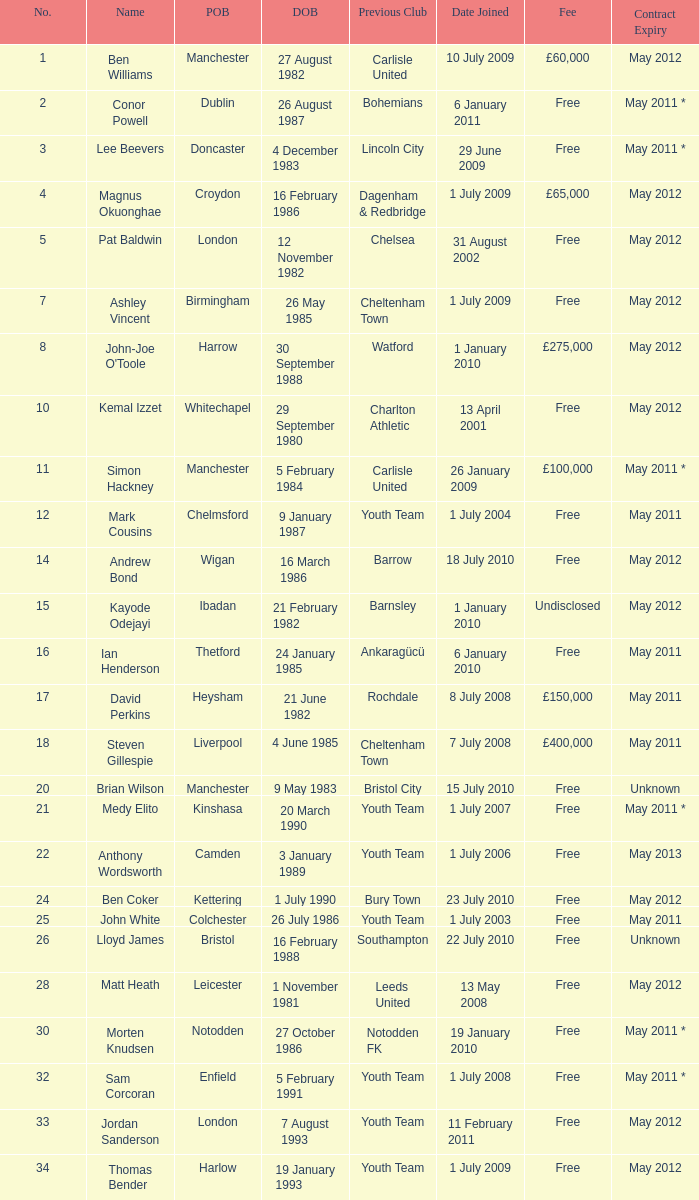For the ben williams name what was the previous club Carlisle United. 